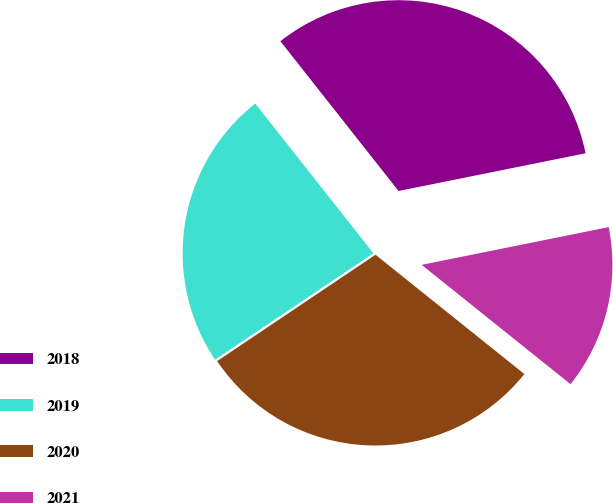<chart> <loc_0><loc_0><loc_500><loc_500><pie_chart><fcel>2018<fcel>2019<fcel>2020<fcel>2021<nl><fcel>32.46%<fcel>23.78%<fcel>29.83%<fcel>13.92%<nl></chart> 